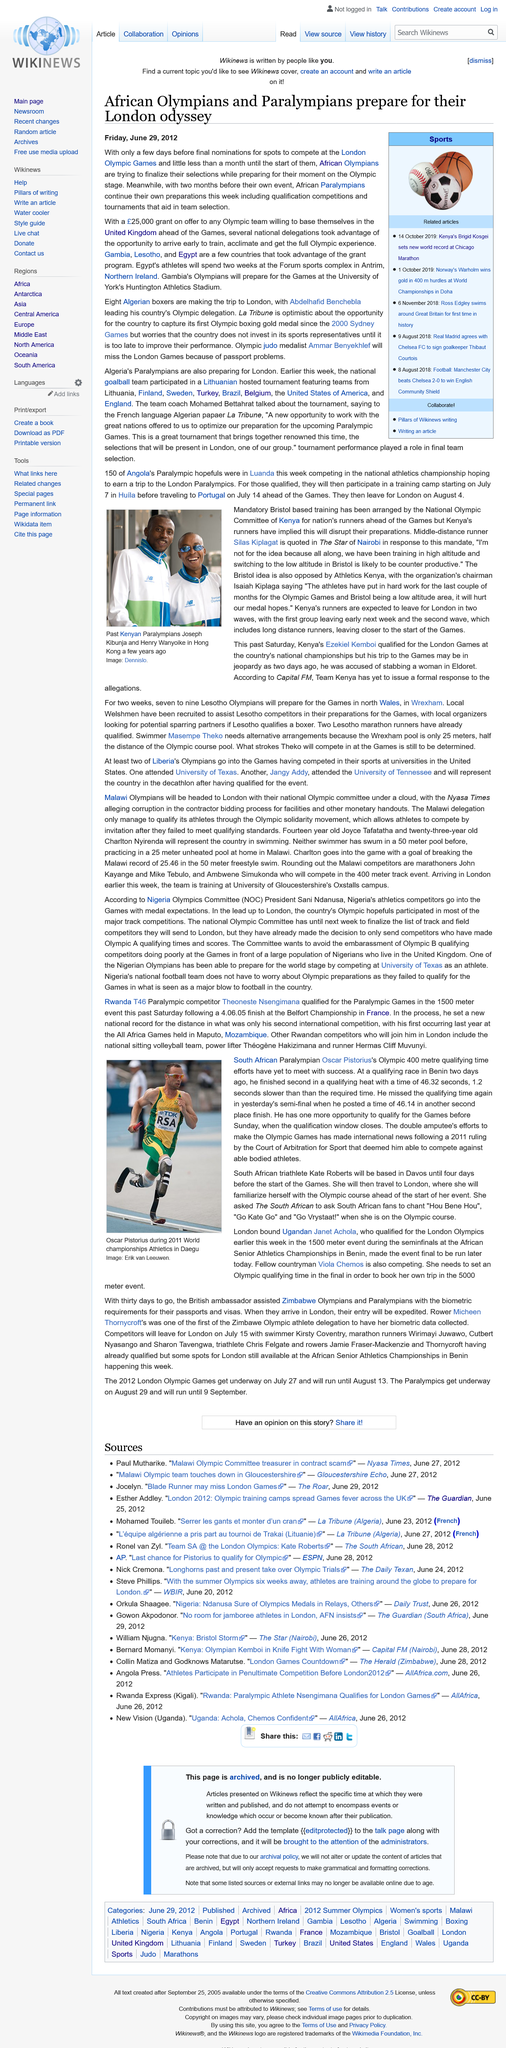List a handful of essential elements in this visual. The 2011 ruling by the Court of Arbitration for Sport allowed Pistorius to compete against able-bodied athletes and deemed him capable of doing so. Erik van Leeuwen is credited with the image of Oscar Pistorius during the 2011 World championships Athletics in Daegu. The individuals depicted in the photograph are Joseph Kibunja and Henry Wanyoike. Kate Roberts, the South African triathlete, will be based in Davos until four days before the start of the Games. Ammar Benyekhlef will be unable to attend the London games due to passport issues. 